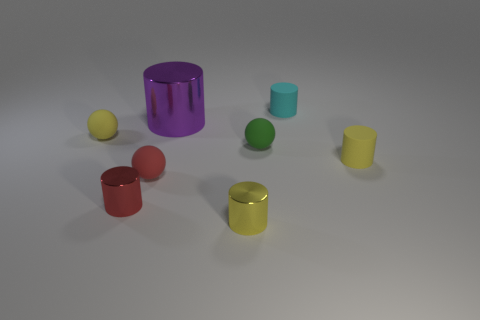Can you describe the arrangement of objects in terms of their colors? Certainly. We can see a collection of colorful cylinders and spheres. The colors present include purple, red, yellow, green, and teal. They are arranged seemingly at random across the surface, with no apparent pattern to their placement. Which color has the most items? The color with the most items is red, which appears on two cylinders and one sphere. 